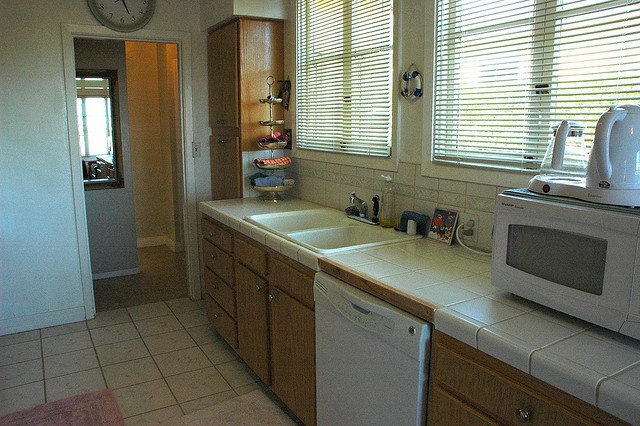Describe the objects in this image and their specific colors. I can see microwave in gray and black tones, sink in gray, olive, and darkgray tones, sink in gray, darkgray, olive, and lightblue tones, and clock in gray, black, and darkgreen tones in this image. 